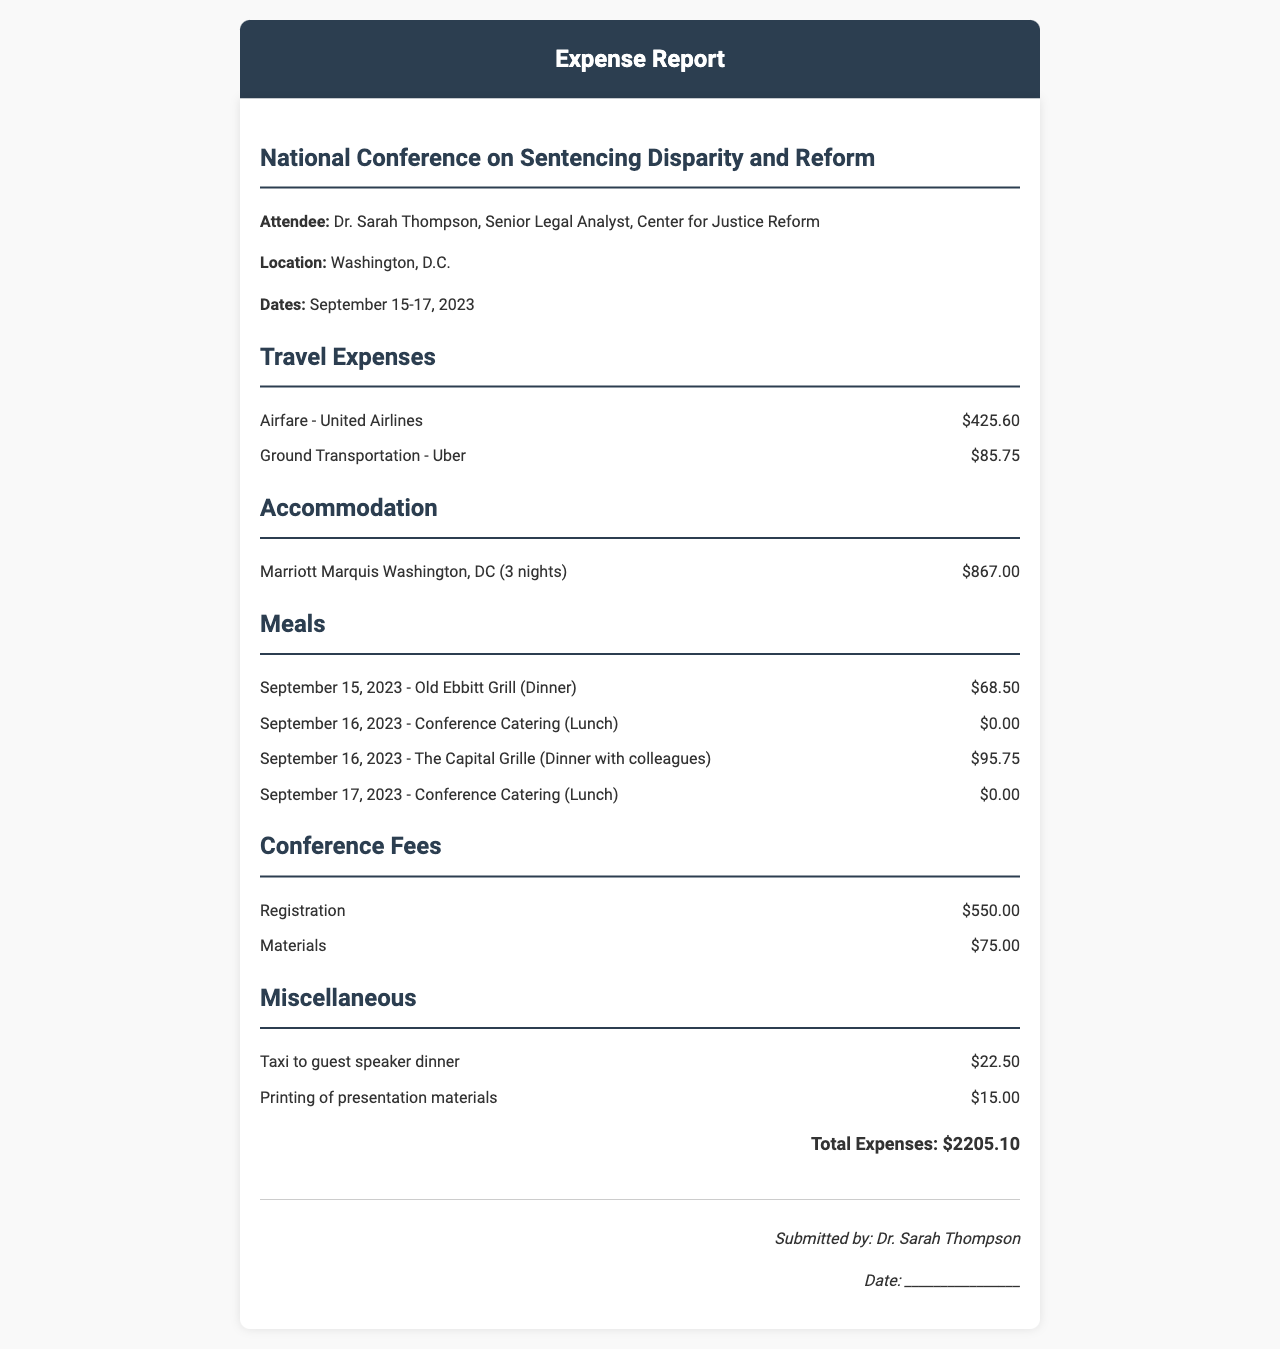What is the name of the conference? The name of the conference is listed as the National Conference on Sentencing Disparity and Reform.
Answer: National Conference on Sentencing Disparity and Reform Who is the attendee? The attendee's name and title are provided in the document, which refers to Dr. Sarah Thompson.
Answer: Dr. Sarah Thompson How many nights was the accommodation? The number of nights stayed in the accommodation is specified as three.
Answer: 3 What was the amount for Airfare? The amount listed for Airfare is directly stated in the travel expenses section as 425.60.
Answer: 425.60 What type of room was booked at the hotel? The room type for the hotel accommodation is mentioned as King Bed, City View.
Answer: King Bed, City View What was the total for Meals? The total meal expenses are calculated based on the sum of individual meal amounts listed in the document.
Answer: 164.25 What is the combined registration and materials fees? The registration and materials fees when added together show the total fees for the conference.
Answer: 625.00 What was the total amount of miscellaneous expenses? The total for miscellaneous expenses is the sum of the listed amounts in that section.
Answer: 37.50 What is the total amount of all expenses? The total expenses reflect the sum of all categories listed in the document, indicated clearly at the bottom.
Answer: 2205.10 